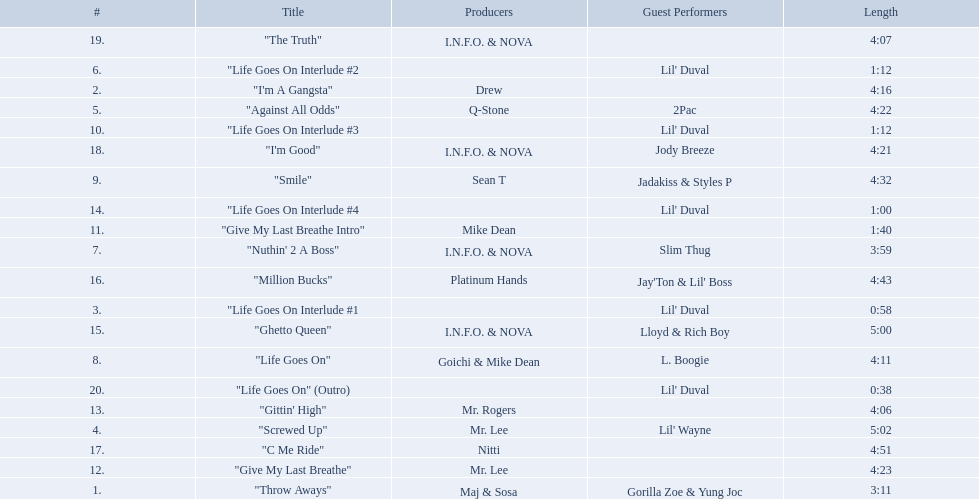What are the song lengths of all the songs on the album? 3:11, 4:16, 0:58, 5:02, 4:22, 1:12, 3:59, 4:11, 4:32, 1:12, 1:40, 4:23, 4:06, 1:00, 5:00, 4:43, 4:51, 4:21, 4:07, 0:38. Which is the longest of these? 5:02. 